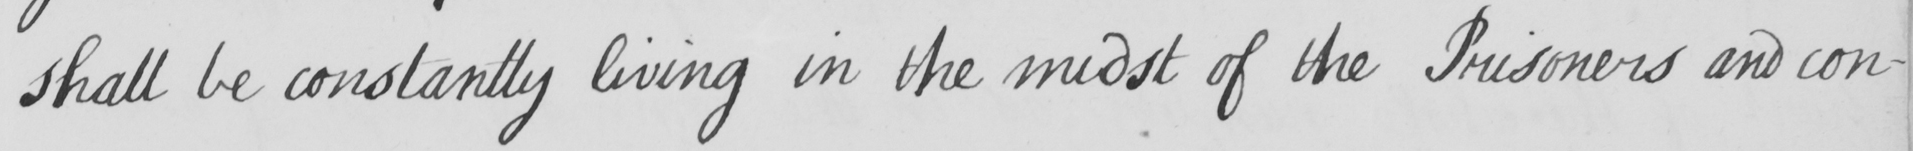Please provide the text content of this handwritten line. shall be constantly living in the midst of the Prisoners and con- 